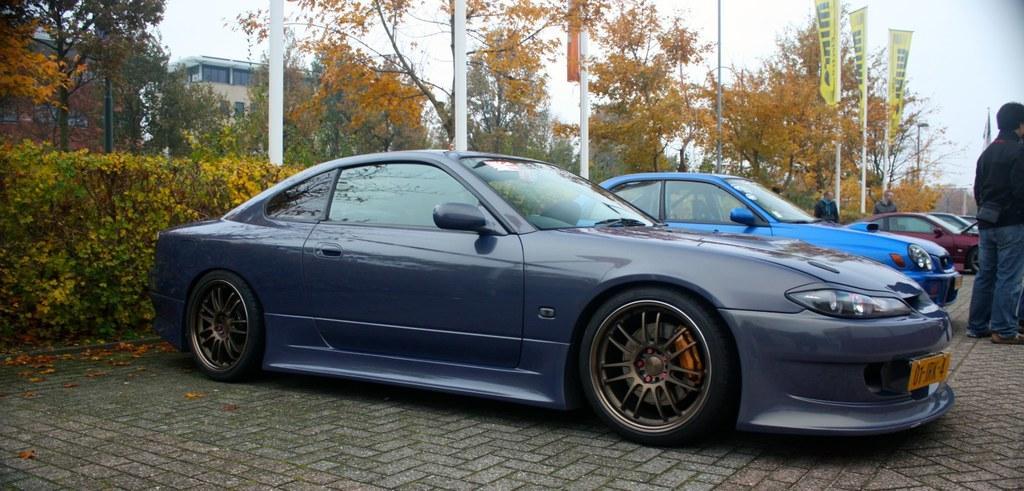Could you give a brief overview of what you see in this image? In this image I can see few cars and I can see a person is standing over here. In the background I can see number of trees, number of poles, flags and buildings. I can also see something is written on these flags. 